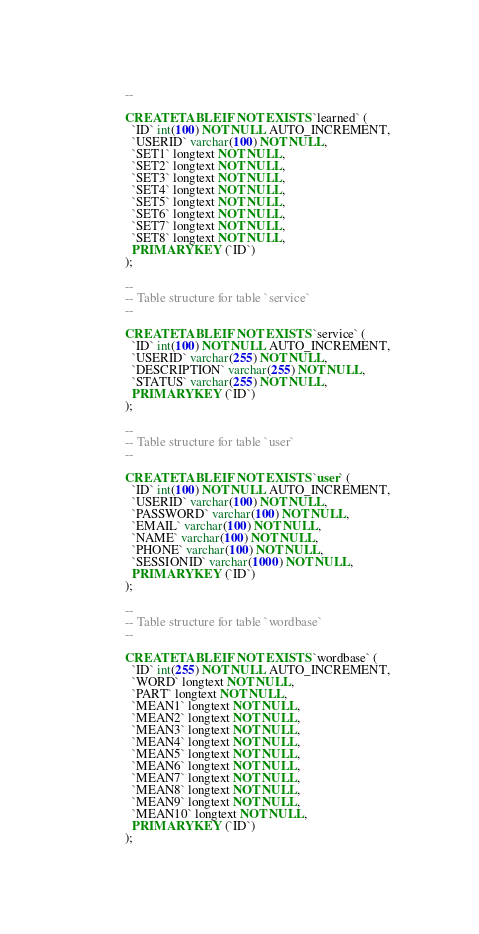<code> <loc_0><loc_0><loc_500><loc_500><_SQL_>--

CREATE TABLE IF NOT EXISTS `learned` (
  `ID` int(100) NOT NULL AUTO_INCREMENT,
  `USERID` varchar(100) NOT NULL,
  `SET1` longtext NOT NULL,
  `SET2` longtext NOT NULL,
  `SET3` longtext NOT NULL,
  `SET4` longtext NOT NULL,
  `SET5` longtext NOT NULL,
  `SET6` longtext NOT NULL,
  `SET7` longtext NOT NULL,
  `SET8` longtext NOT NULL,
  PRIMARY KEY (`ID`)
);

--
-- Table structure for table `service`
--

CREATE TABLE IF NOT EXISTS `service` (
  `ID` int(100) NOT NULL AUTO_INCREMENT,
  `USERID` varchar(255) NOT NULL,
  `DESCRIPTION` varchar(255) NOT NULL,
  `STATUS` varchar(255) NOT NULL,
  PRIMARY KEY (`ID`)
);

--
-- Table structure for table `user`
--

CREATE TABLE IF NOT EXISTS `user` (
  `ID` int(100) NOT NULL AUTO_INCREMENT,
  `USERID` varchar(100) NOT NULL,
  `PASSWORD` varchar(100) NOT NULL,
  `EMAIL` varchar(100) NOT NULL,
  `NAME` varchar(100) NOT NULL,
  `PHONE` varchar(100) NOT NULL,
  `SESSIONID` varchar(1000) NOT NULL,
  PRIMARY KEY (`ID`)
);

--
-- Table structure for table `wordbase`
--

CREATE TABLE IF NOT EXISTS `wordbase` (
  `ID` int(255) NOT NULL AUTO_INCREMENT,
  `WORD` longtext NOT NULL,
  `PART` longtext NOT NULL,
  `MEAN1` longtext NOT NULL,
  `MEAN2` longtext NOT NULL,
  `MEAN3` longtext NOT NULL,
  `MEAN4` longtext NOT NULL,
  `MEAN5` longtext NOT NULL,
  `MEAN6` longtext NOT NULL,
  `MEAN7` longtext NOT NULL,
  `MEAN8` longtext NOT NULL,
  `MEAN9` longtext NOT NULL,
  `MEAN10` longtext NOT NULL,
  PRIMARY KEY (`ID`)
);</code> 